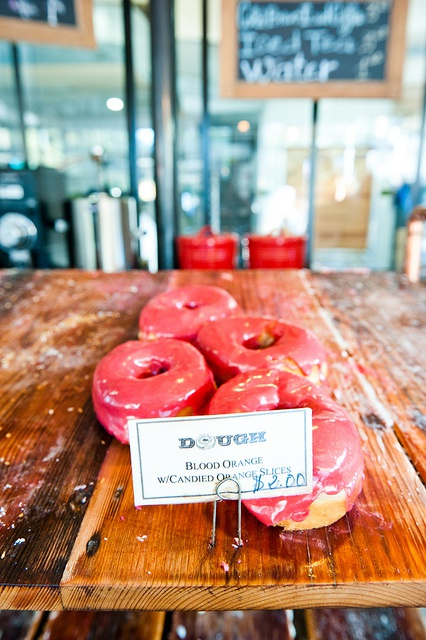Describe the objects in this image and their specific colors. I can see dining table in darkblue, white, lightpink, salmon, and tan tones, donut in darkblue, lightpink, salmon, pink, and tan tones, donut in darkblue, salmon, lightpink, and red tones, donut in darkblue, salmon, lightpink, red, and pink tones, and donut in darkblue, salmon, and red tones in this image. 